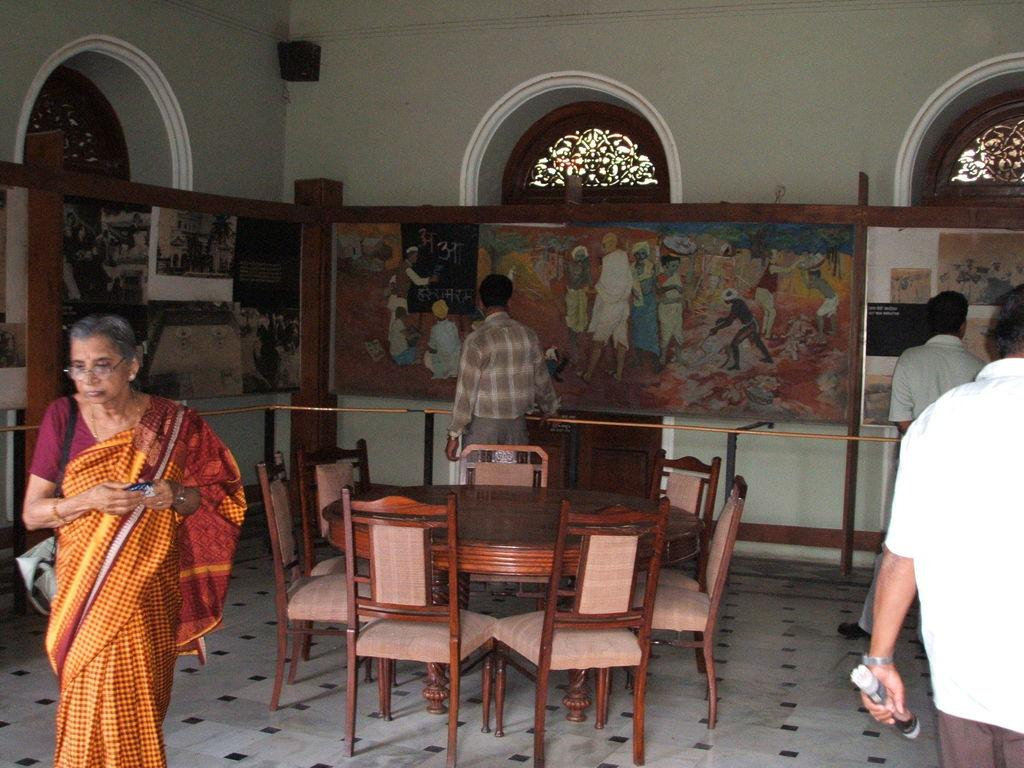What type of furniture is present in the image? There are chairs with a dining table in the image. What is happening on the left side of the image? A woman is walking on the left side of the image. What can be seen on the wall in the image? There are pictures on the wall. What part of the room is visible in the image? The wall is visible in the image. Can you see the tiger's toes in the image? There is no tiger or toes present in the image. What type of game is being played in the image? There is no game or play depicted in the image. 